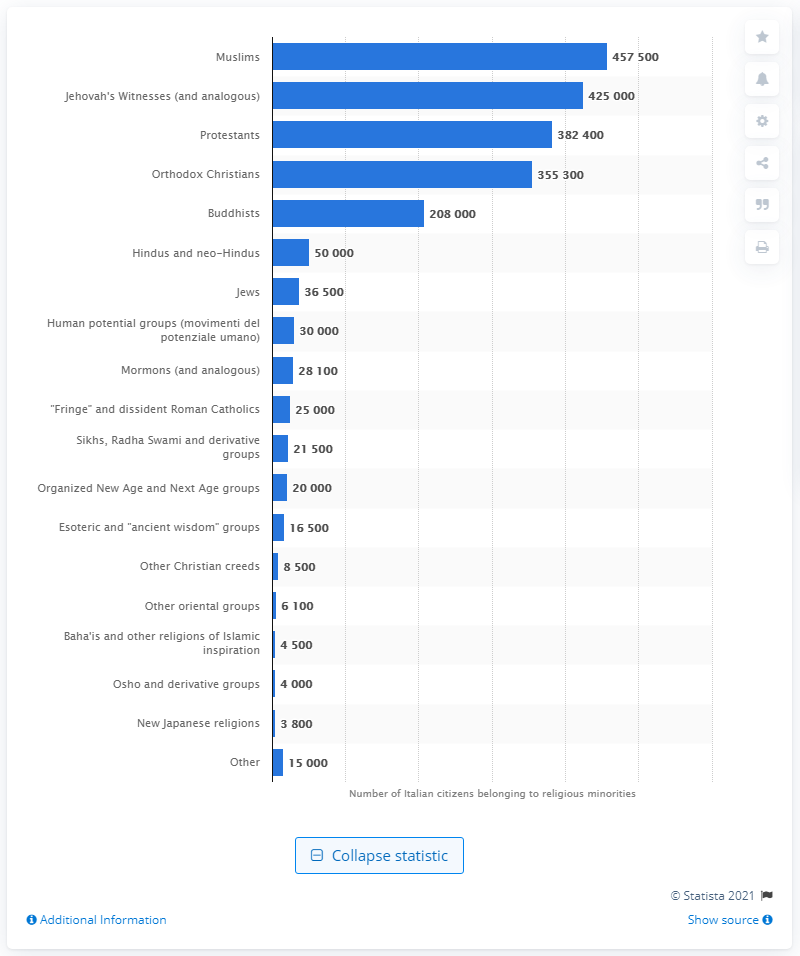Indicate a few pertinent items in this graphic. It is estimated that approximately 425,000 Italian citizens are Jehovah's Witnesses. 